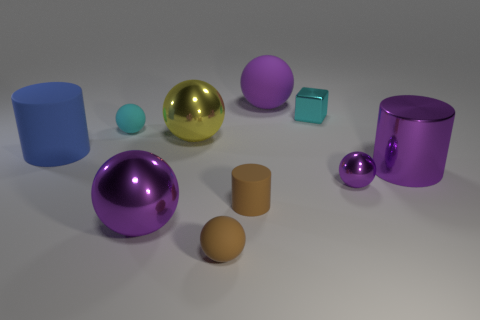Is the material of the tiny cylinder the same as the blue thing?
Your response must be concise. Yes. Are there any other purple rubber objects of the same shape as the purple matte object?
Offer a very short reply. No. There is a metal ball right of the shiny block; is its color the same as the small cylinder?
Provide a succinct answer. No. There is a purple metal ball right of the yellow object; is its size the same as the purple metal ball to the left of the brown rubber sphere?
Your answer should be compact. No. There is a yellow thing that is made of the same material as the tiny block; what is its size?
Provide a short and direct response. Large. What number of things are both on the left side of the tiny brown cylinder and behind the big blue thing?
Offer a very short reply. 2. How many objects are either tiny cyan metallic objects or purple shiny objects that are in front of the big metallic cylinder?
Ensure brevity in your answer.  3. There is a small metal object that is the same color as the metallic cylinder; what is its shape?
Your response must be concise. Sphere. There is a large cylinder that is right of the big rubber sphere; what color is it?
Ensure brevity in your answer.  Purple. What number of things are tiny cyan objects on the right side of the large purple matte object or big cylinders?
Offer a terse response. 3. 